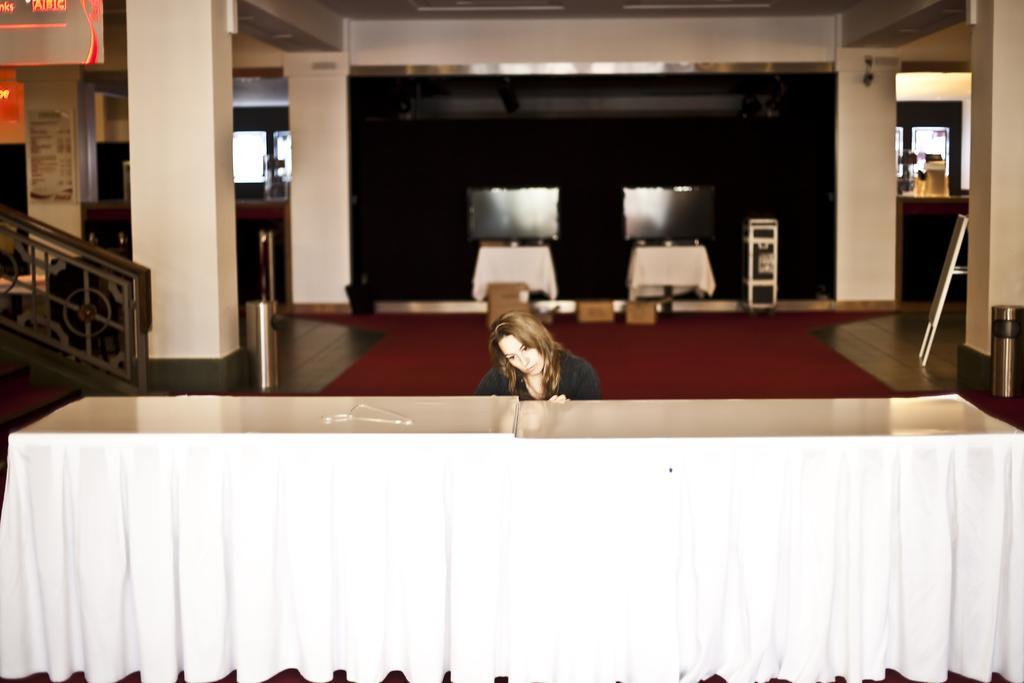Describe this image in one or two sentences. In this image i can see a woman in front of a table. I can also see there is a red carpet on the floor. 